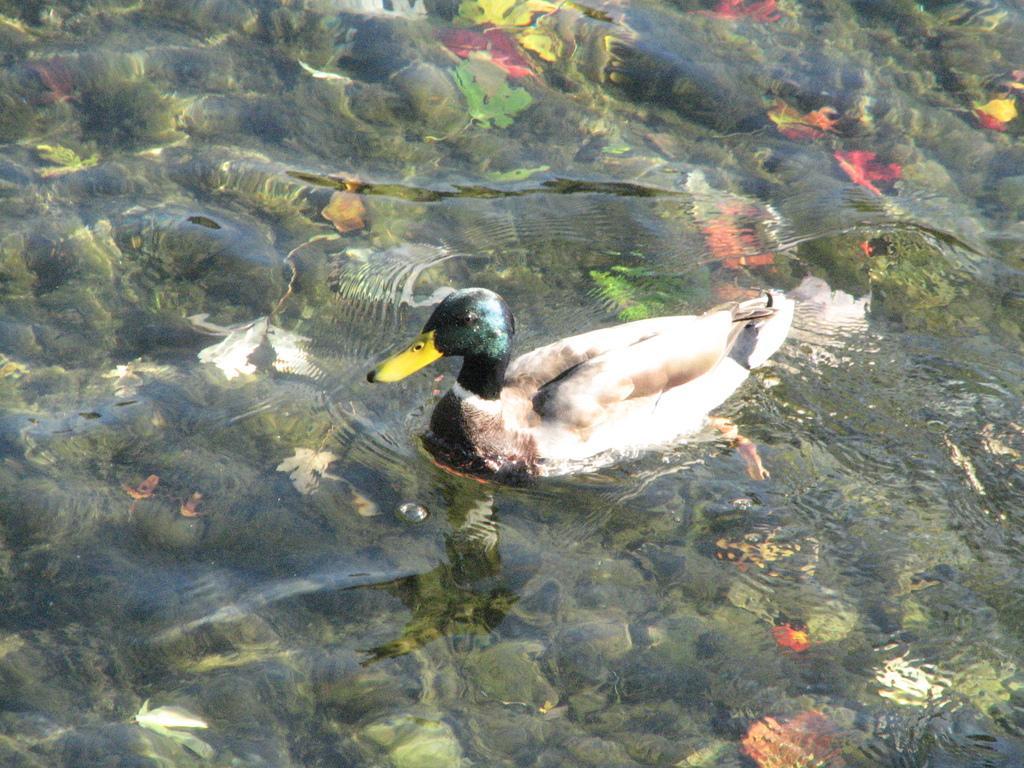In one or two sentences, can you explain what this image depicts? In this image I can see in the middle a duck is swimming in the water. 